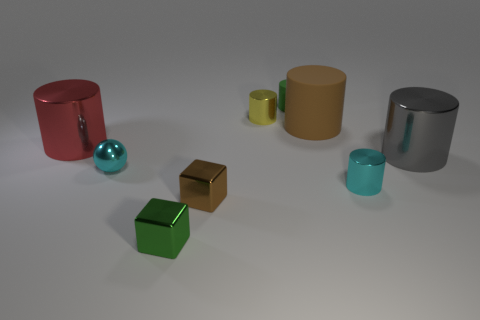Subtract all yellow cylinders. How many cylinders are left? 5 Subtract all large gray cylinders. How many cylinders are left? 5 Subtract all blue cylinders. Subtract all red spheres. How many cylinders are left? 6 Add 1 small green cylinders. How many objects exist? 10 Subtract all cylinders. How many objects are left? 3 Subtract 1 red cylinders. How many objects are left? 8 Subtract all small green metal cubes. Subtract all small green rubber objects. How many objects are left? 7 Add 2 big rubber objects. How many big rubber objects are left? 3 Add 9 cyan rubber balls. How many cyan rubber balls exist? 9 